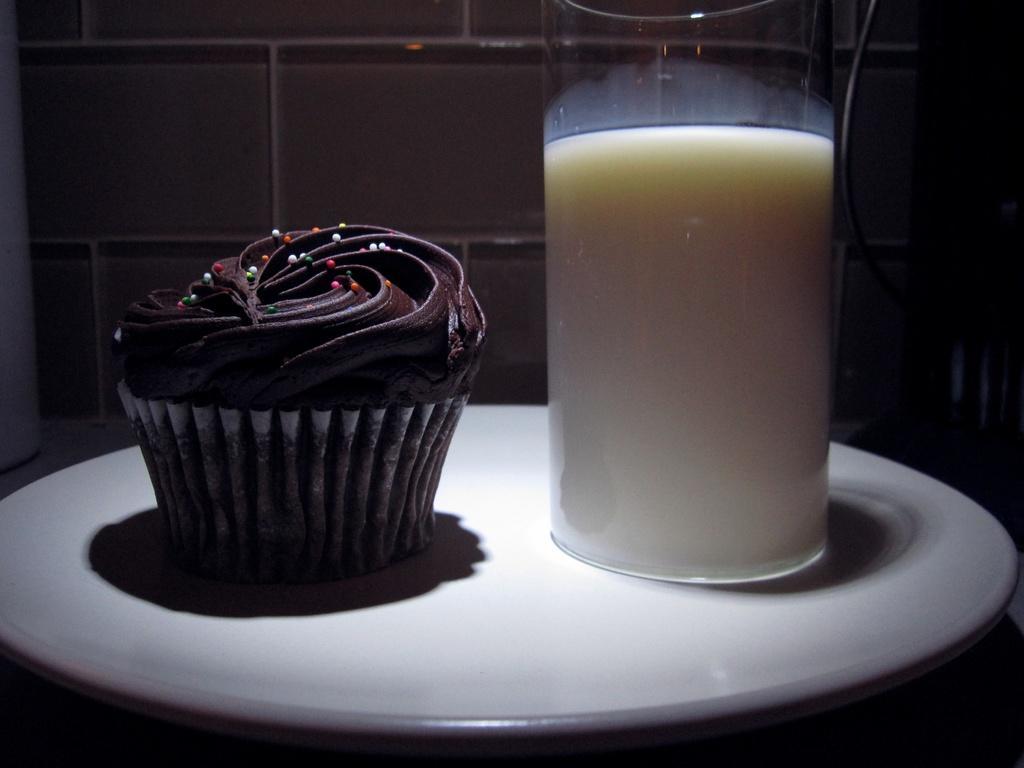Describe this image in one or two sentences. Here I can see a glass which consists of milk and a cupcake are placed on a plate. In the background there is a wall. 